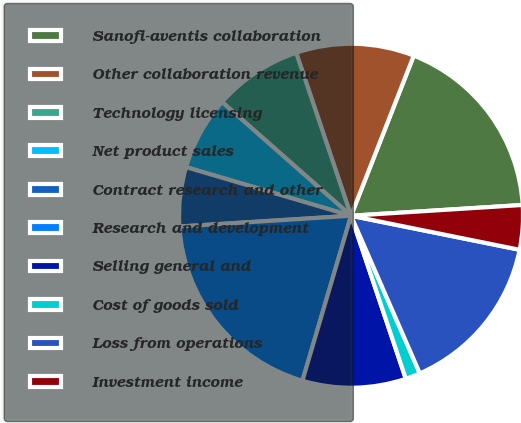Convert chart to OTSL. <chart><loc_0><loc_0><loc_500><loc_500><pie_chart><fcel>Sanofi-aventis collaboration<fcel>Other collaboration revenue<fcel>Technology licensing<fcel>Net product sales<fcel>Contract research and other<fcel>Research and development<fcel>Selling general and<fcel>Cost of goods sold<fcel>Loss from operations<fcel>Investment income<nl><fcel>18.06%<fcel>11.11%<fcel>8.33%<fcel>6.94%<fcel>5.56%<fcel>19.44%<fcel>9.72%<fcel>1.39%<fcel>15.28%<fcel>4.17%<nl></chart> 